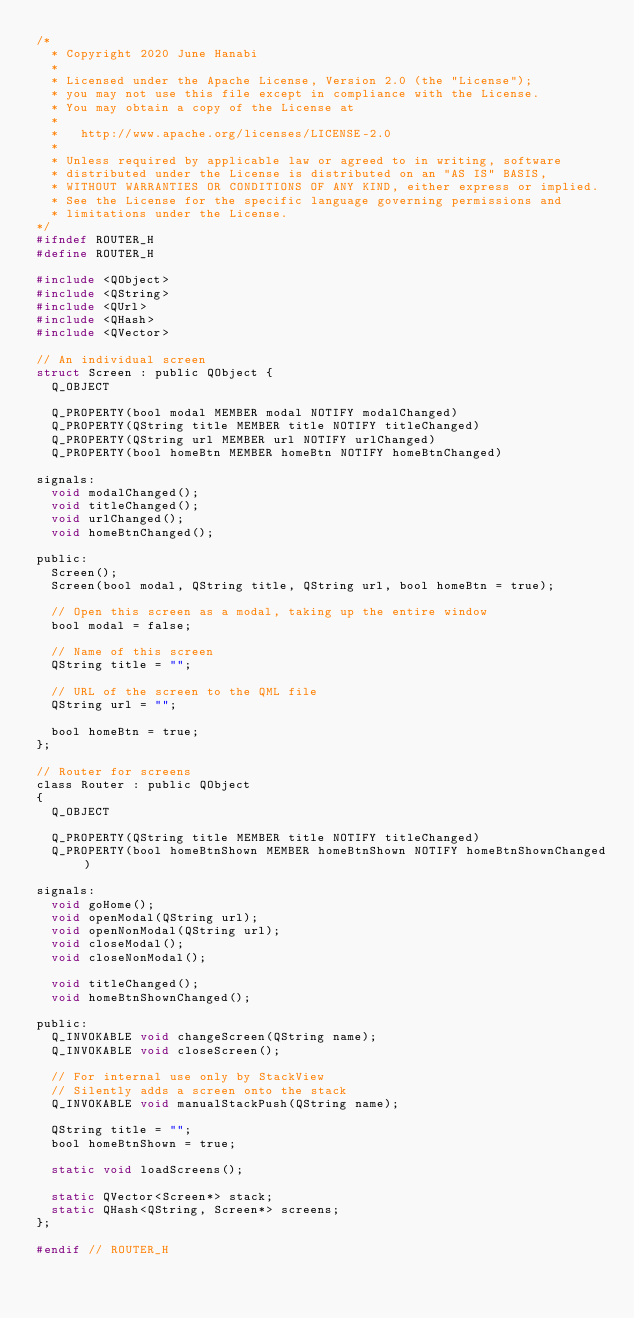<code> <loc_0><loc_0><loc_500><loc_500><_C_>/*
  * Copyright 2020 June Hanabi
  *
  * Licensed under the Apache License, Version 2.0 (the "License");
  * you may not use this file except in compliance with the License.
  * You may obtain a copy of the License at
  *
  *   http://www.apache.org/licenses/LICENSE-2.0
  *
  * Unless required by applicable law or agreed to in writing, software
  * distributed under the License is distributed on an "AS IS" BASIS,
  * WITHOUT WARRANTIES OR CONDITIONS OF ANY KIND, either express or implied.
  * See the License for the specific language governing permissions and
  * limitations under the License.
*/
#ifndef ROUTER_H
#define ROUTER_H

#include <QObject>
#include <QString>
#include <QUrl>
#include <QHash>
#include <QVector>

// An individual screen
struct Screen : public QObject {
  Q_OBJECT

  Q_PROPERTY(bool modal MEMBER modal NOTIFY modalChanged)
  Q_PROPERTY(QString title MEMBER title NOTIFY titleChanged)
  Q_PROPERTY(QString url MEMBER url NOTIFY urlChanged)
  Q_PROPERTY(bool homeBtn MEMBER homeBtn NOTIFY homeBtnChanged)

signals:
  void modalChanged();
  void titleChanged();
  void urlChanged();
  void homeBtnChanged();

public:
  Screen();
  Screen(bool modal, QString title, QString url, bool homeBtn = true);

  // Open this screen as a modal, taking up the entire window
  bool modal = false;

  // Name of this screen
  QString title = "";

  // URL of the screen to the QML file
  QString url = "";

  bool homeBtn = true;
};

// Router for screens
class Router : public QObject
{
  Q_OBJECT

  Q_PROPERTY(QString title MEMBER title NOTIFY titleChanged)
  Q_PROPERTY(bool homeBtnShown MEMBER homeBtnShown NOTIFY homeBtnShownChanged)

signals:
  void goHome();
  void openModal(QString url);
  void openNonModal(QString url);
  void closeModal();
  void closeNonModal();

  void titleChanged();
  void homeBtnShownChanged();

public:
  Q_INVOKABLE void changeScreen(QString name);
  Q_INVOKABLE void closeScreen();

  // For internal use only by StackView
  // Silently adds a screen onto the stack
  Q_INVOKABLE void manualStackPush(QString name);

  QString title = "";
  bool homeBtnShown = true;

  static void loadScreens();

  static QVector<Screen*> stack;
  static QHash<QString, Screen*> screens;
};

#endif // ROUTER_H
</code> 